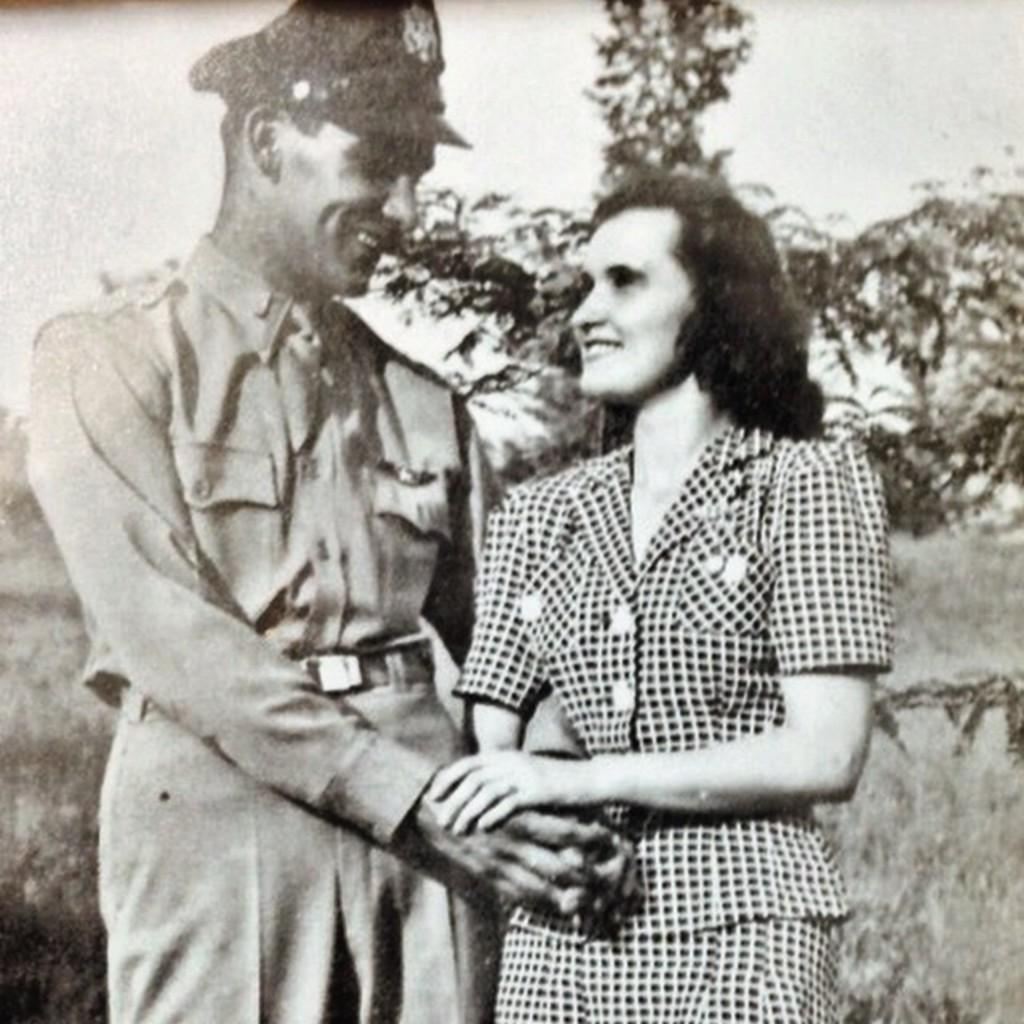What is the color scheme of the image? The image is black and white. How many people can be seen in the image? There are a few people in the image. What is visible on the ground in the image? There are objects on the ground visible in the image. What type of vegetation is present in the image? There are trees in the image. What part of the natural environment is visible in the image? The sky is visible in the image. What type of bean is being used to make a sweater in the image? There is no bean or sweater present in the image. How many bites can be seen being taken out of the trees in the image? There are no bites taken out of the trees in the image; the trees are intact. 